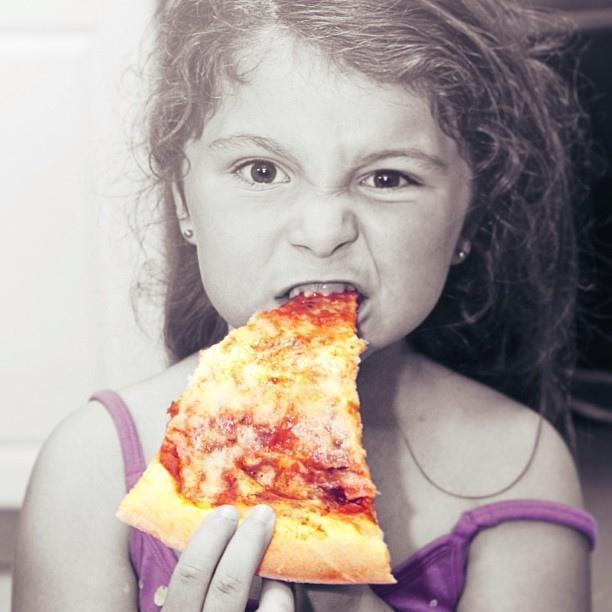Is this affirmation: "The pizza is detached from the person." correct?
Answer yes or no. No. 